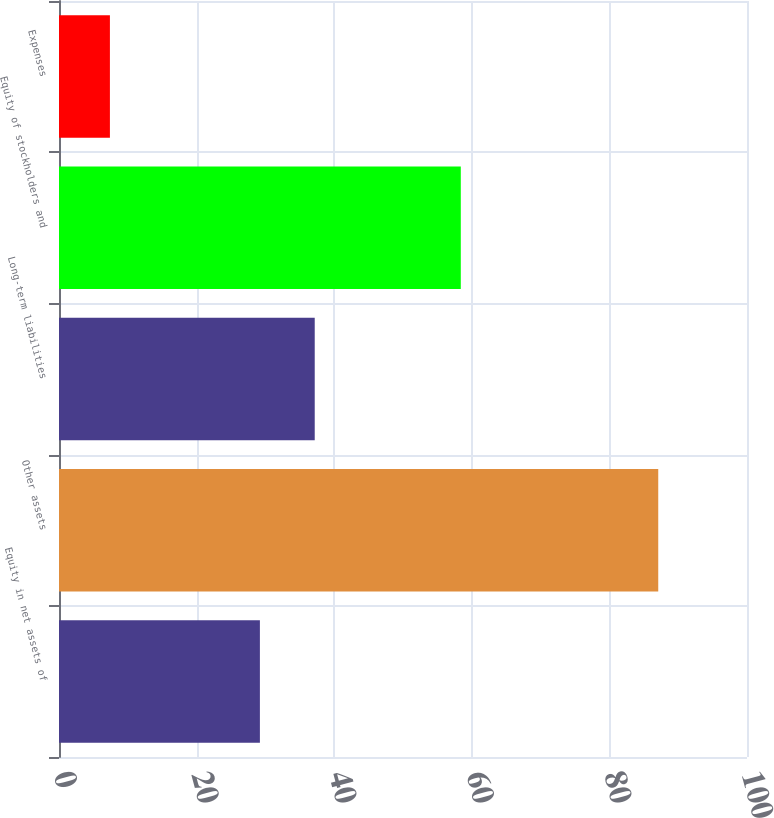Convert chart to OTSL. <chart><loc_0><loc_0><loc_500><loc_500><bar_chart><fcel>Equity in net assets of<fcel>Other assets<fcel>Long-term liabilities<fcel>Equity of stockholders and<fcel>Expenses<nl><fcel>29.2<fcel>87.1<fcel>37.17<fcel>58.4<fcel>7.4<nl></chart> 